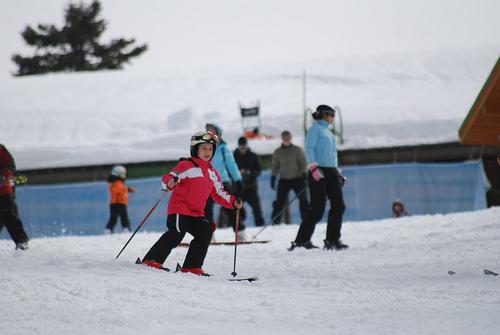Is the boy excited about skiing?
Answer briefly. Yes. Where is the woman walking?
Write a very short answer. On snow. Is that water in the background?
Quick response, please. No. Is the boy fully clothed?
Keep it brief. Yes. Is the person on the right wearing a brown jacket?
Quick response, please. No. Is he skiing?
Answer briefly. Yes. Is the woman wearing ski goggles?
Short answer required. Yes. Is the weather sunny?
Answer briefly. No. 